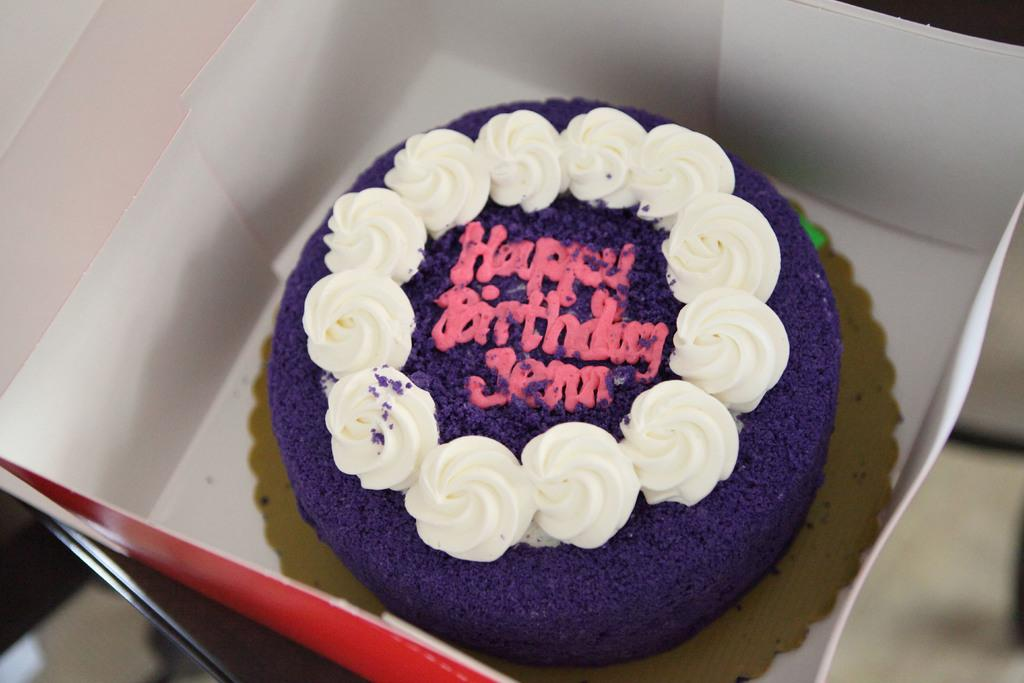What is inside the box that is visible in the image? There is a birthday cake in a box in the image. Can you describe the condition of the birthday cake? The birthday cake is inside a box, so its specific appearance cannot be determined from the image. What might be the occasion for the cake in the image? The presence of a birthday cake suggests that it might be for a birthday celebration. What type of rice can be seen growing in the image? There is no rice present in the image; it features a birthday cake in a box. What kitchen appliance is visible in the image? There is no kitchen appliance present in the image; it features a birthday cake in a box. 